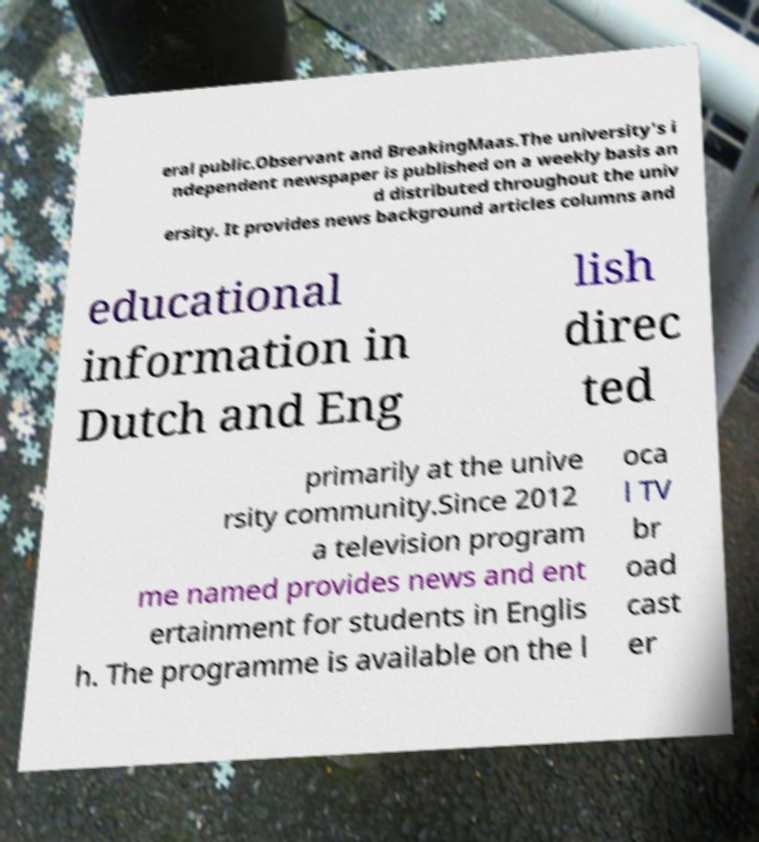Can you read and provide the text displayed in the image?This photo seems to have some interesting text. Can you extract and type it out for me? eral public.Observant and BreakingMaas.The university's i ndependent newspaper is published on a weekly basis an d distributed throughout the univ ersity. It provides news background articles columns and educational information in Dutch and Eng lish direc ted primarily at the unive rsity community.Since 2012 a television program me named provides news and ent ertainment for students in Englis h. The programme is available on the l oca l TV br oad cast er 